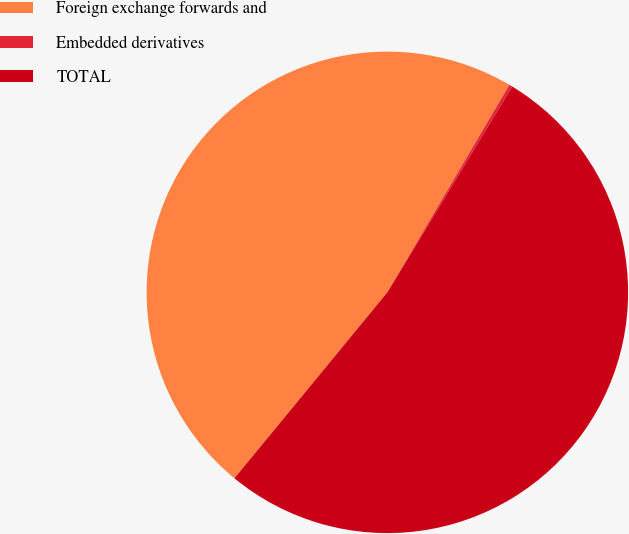Convert chart. <chart><loc_0><loc_0><loc_500><loc_500><pie_chart><fcel>Foreign exchange forwards and<fcel>Embedded derivatives<fcel>TOTAL<nl><fcel>47.51%<fcel>0.22%<fcel>52.27%<nl></chart> 